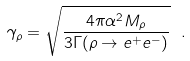Convert formula to latex. <formula><loc_0><loc_0><loc_500><loc_500>\gamma _ { \rho } = \sqrt { \frac { 4 \pi \alpha ^ { 2 } M _ { \rho } } { 3 \Gamma ( \rho \to e ^ { + } e ^ { - } ) } } \ .</formula> 